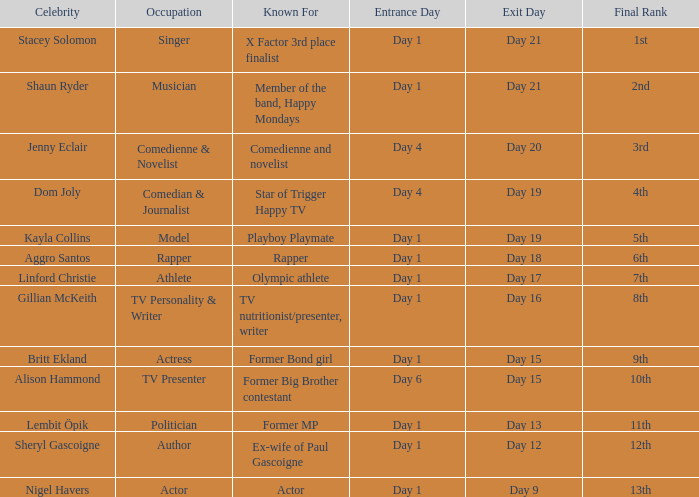In what area is dom joly well-known? Comedian, journalist and star of Trigger Happy TV. 